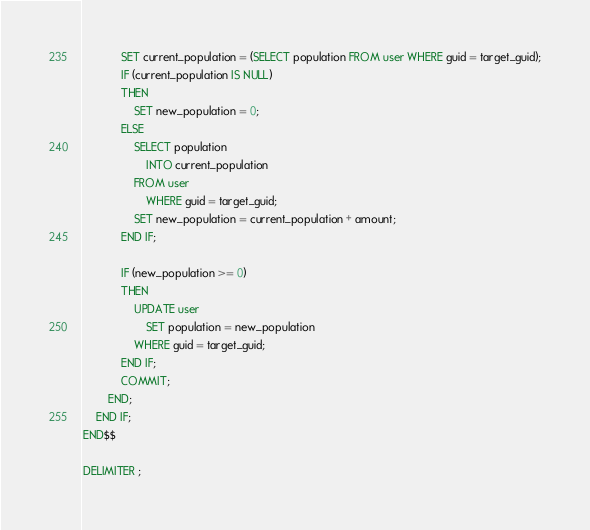<code> <loc_0><loc_0><loc_500><loc_500><_SQL_>			SET current_population = (SELECT population FROM user WHERE guid = target_guid);
			IF (current_population IS NULL)
			THEN
				SET new_population = 0;
			ELSE
				SELECT population
					INTO current_population
				FROM user
					WHERE guid = target_guid;
				SET new_population = current_population + amount;
			END IF;
			
            IF (new_population >= 0)
            THEN
				UPDATE user
					SET population = new_population
				WHERE guid = target_guid;
            END IF;
			COMMIT;
        END;
    END IF;
END$$

DELIMITER ;
</code> 